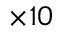<formula> <loc_0><loc_0><loc_500><loc_500>\times 1 0</formula> 